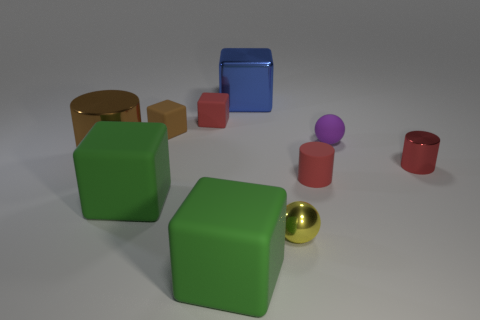What color is the matte cylinder?
Offer a very short reply. Red. Are there any other things that have the same shape as the yellow object?
Offer a very short reply. Yes. The other matte thing that is the same shape as the small yellow thing is what color?
Keep it short and to the point. Purple. Is the shape of the small purple rubber object the same as the big brown metal object?
Give a very brief answer. No. How many cubes are small brown things or big blue metallic things?
Provide a succinct answer. 2. What is the color of the cylinder that is the same material as the purple ball?
Give a very brief answer. Red. Does the brown object that is in front of the brown rubber object have the same size as the matte sphere?
Make the answer very short. No. Is the material of the big blue block the same as the ball that is in front of the red metallic cylinder?
Offer a very short reply. Yes. What is the color of the small rubber object behind the brown matte object?
Keep it short and to the point. Red. There is a tiny ball that is behind the big cylinder; are there any metal spheres on the right side of it?
Ensure brevity in your answer.  No. 